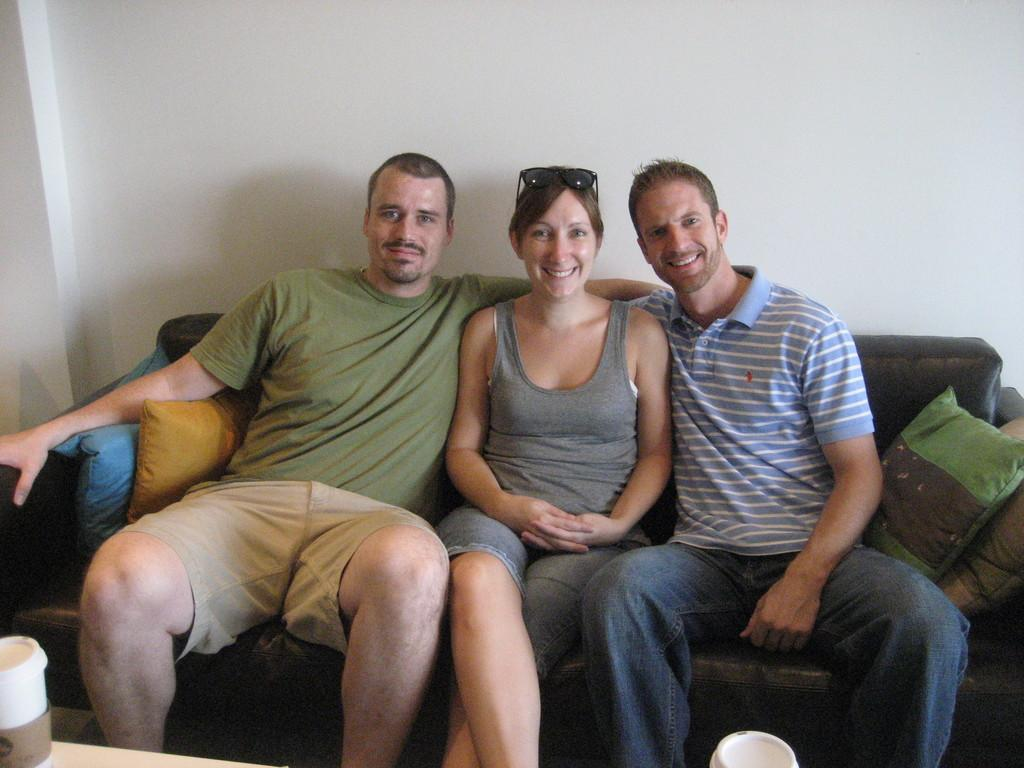How many people are in the image? There are three persons in the image. What are the persons doing in the image? The persons are sitting on a sofa and laughing. What can be seen in the background of the image? There is a wall in the background of the image. What might be used for additional comfort while sitting on the sofa? There are cushions present in the image. What type of grass is growing on the sofa in the image? There is no grass present on the sofa in the image. What offer is being made by the persons sitting on the sofa? There is no offer being made by the persons in the image. 